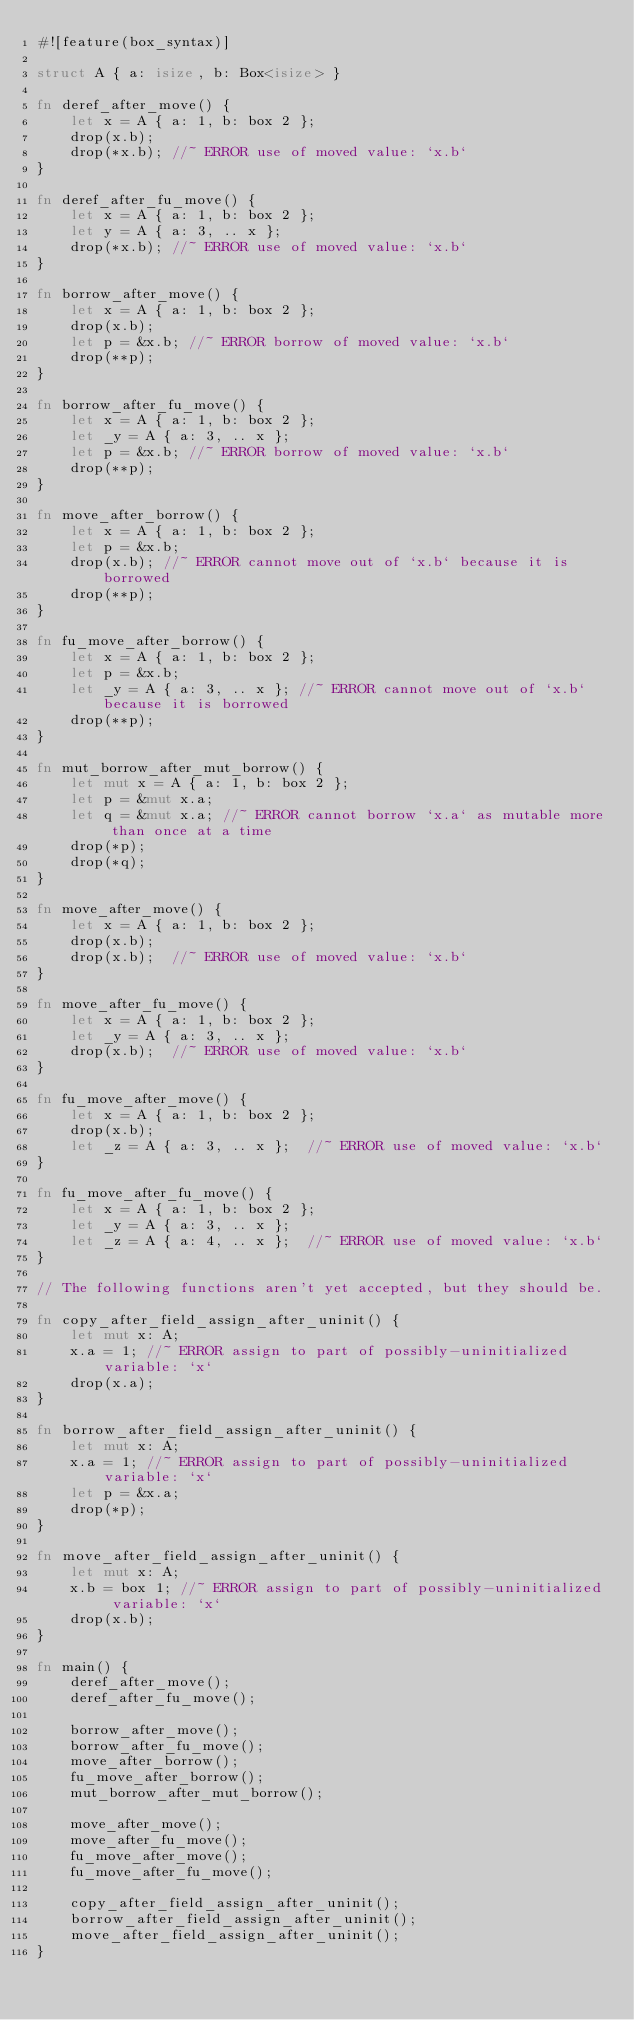<code> <loc_0><loc_0><loc_500><loc_500><_Rust_>#![feature(box_syntax)]

struct A { a: isize, b: Box<isize> }

fn deref_after_move() {
    let x = A { a: 1, b: box 2 };
    drop(x.b);
    drop(*x.b); //~ ERROR use of moved value: `x.b`
}

fn deref_after_fu_move() {
    let x = A { a: 1, b: box 2 };
    let y = A { a: 3, .. x };
    drop(*x.b); //~ ERROR use of moved value: `x.b`
}

fn borrow_after_move() {
    let x = A { a: 1, b: box 2 };
    drop(x.b);
    let p = &x.b; //~ ERROR borrow of moved value: `x.b`
    drop(**p);
}

fn borrow_after_fu_move() {
    let x = A { a: 1, b: box 2 };
    let _y = A { a: 3, .. x };
    let p = &x.b; //~ ERROR borrow of moved value: `x.b`
    drop(**p);
}

fn move_after_borrow() {
    let x = A { a: 1, b: box 2 };
    let p = &x.b;
    drop(x.b); //~ ERROR cannot move out of `x.b` because it is borrowed
    drop(**p);
}

fn fu_move_after_borrow() {
    let x = A { a: 1, b: box 2 };
    let p = &x.b;
    let _y = A { a: 3, .. x }; //~ ERROR cannot move out of `x.b` because it is borrowed
    drop(**p);
}

fn mut_borrow_after_mut_borrow() {
    let mut x = A { a: 1, b: box 2 };
    let p = &mut x.a;
    let q = &mut x.a; //~ ERROR cannot borrow `x.a` as mutable more than once at a time
    drop(*p);
    drop(*q);
}

fn move_after_move() {
    let x = A { a: 1, b: box 2 };
    drop(x.b);
    drop(x.b);  //~ ERROR use of moved value: `x.b`
}

fn move_after_fu_move() {
    let x = A { a: 1, b: box 2 };
    let _y = A { a: 3, .. x };
    drop(x.b);  //~ ERROR use of moved value: `x.b`
}

fn fu_move_after_move() {
    let x = A { a: 1, b: box 2 };
    drop(x.b);
    let _z = A { a: 3, .. x };  //~ ERROR use of moved value: `x.b`
}

fn fu_move_after_fu_move() {
    let x = A { a: 1, b: box 2 };
    let _y = A { a: 3, .. x };
    let _z = A { a: 4, .. x };  //~ ERROR use of moved value: `x.b`
}

// The following functions aren't yet accepted, but they should be.

fn copy_after_field_assign_after_uninit() {
    let mut x: A;
    x.a = 1; //~ ERROR assign to part of possibly-uninitialized variable: `x`
    drop(x.a);
}

fn borrow_after_field_assign_after_uninit() {
    let mut x: A;
    x.a = 1; //~ ERROR assign to part of possibly-uninitialized variable: `x`
    let p = &x.a;
    drop(*p);
}

fn move_after_field_assign_after_uninit() {
    let mut x: A;
    x.b = box 1; //~ ERROR assign to part of possibly-uninitialized variable: `x`
    drop(x.b);
}

fn main() {
    deref_after_move();
    deref_after_fu_move();

    borrow_after_move();
    borrow_after_fu_move();
    move_after_borrow();
    fu_move_after_borrow();
    mut_borrow_after_mut_borrow();

    move_after_move();
    move_after_fu_move();
    fu_move_after_move();
    fu_move_after_fu_move();

    copy_after_field_assign_after_uninit();
    borrow_after_field_assign_after_uninit();
    move_after_field_assign_after_uninit();
}
</code> 